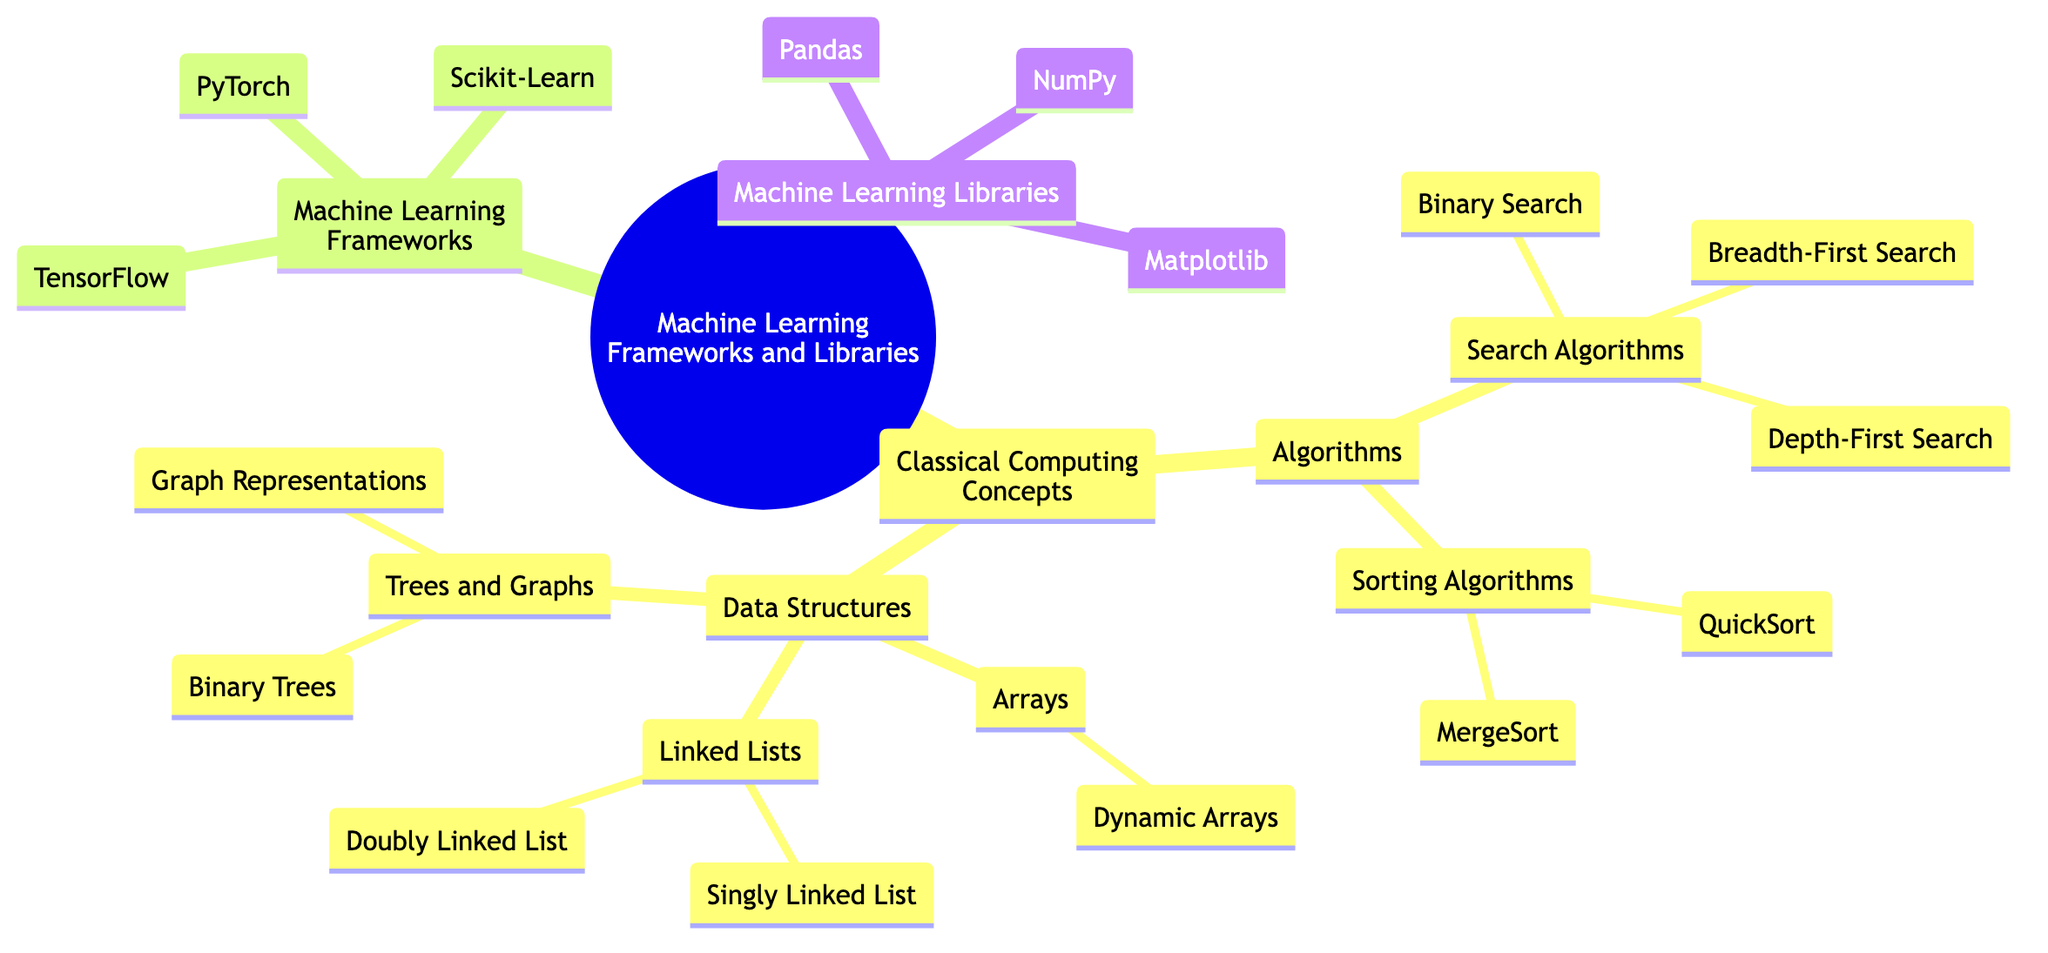What is the root of the family tree? The root node of the tree is "Machine Learning Frameworks and Libraries." This can be identified as the top-level node that all other nodes branch from.
Answer: Machine Learning Frameworks and Libraries How many children does "Classical Computing Concepts" have? "Classical Computing Concepts" has two direct children: "Algorithms" and "Data Structures." By counting the children under this node, we find that there are two.
Answer: 2 What are two examples of Sorting Algorithms? Under the "Sorting Algorithms" node, two examples listed are "QuickSort" and "MergeSort." These are specified directly under the "Sorting Algorithms" category.
Answer: QuickSort, MergeSort Which framework is developed by Google? The framework listed directly beneath "Machine Learning Frameworks" that is developed by Google is "TensorFlow." This can be found as a child of the "Machine Learning Frameworks" node.
Answer: TensorFlow Name a library for data analysis. "Pandas" is mentioned under the "Machine Learning Libraries" section as an open-source data analysis and manipulation tool. It is a direct child of the "Machine Learning Libraries" node.
Answer: Pandas Which type of trees are mentioned under Data Structures? The "Trees and Graphs" node under "Data Structures" mentions "Binary Trees" as one of its subcategories. Thus, under trees, "Binary Trees" is specified directly.
Answer: Binary Trees How many libraries are listed in the diagram? The total number of libraries listed under "Machine Learning Libraries" is three: "NumPy," "Pandas," and "Matplotlib." By counting these children, we confirm there are three libraries.
Answer: 3 What is the relationship between "Algorithms" and "Data Structures"? "Algorithms" and "Data Structures" are both children of the "Classical Computing Concepts" node, indicating a sibling relationship as they share a common parent.
Answer: Sibling relationship What does PyTorch specialize in? "PyTorch," located under "Machine Learning Frameworks," is identified as an open-source machine learning library developed by Facebook’s AI Research lab. This indicates its specialization within the domain.
Answer: Open-source machine learning library How many examples are provided under Search Algorithms? There are three examples listed under "Search Algorithms": "Binary Search," "Breadth-First Search," and "Depth-First Search." Counting these provides the total.
Answer: 3 